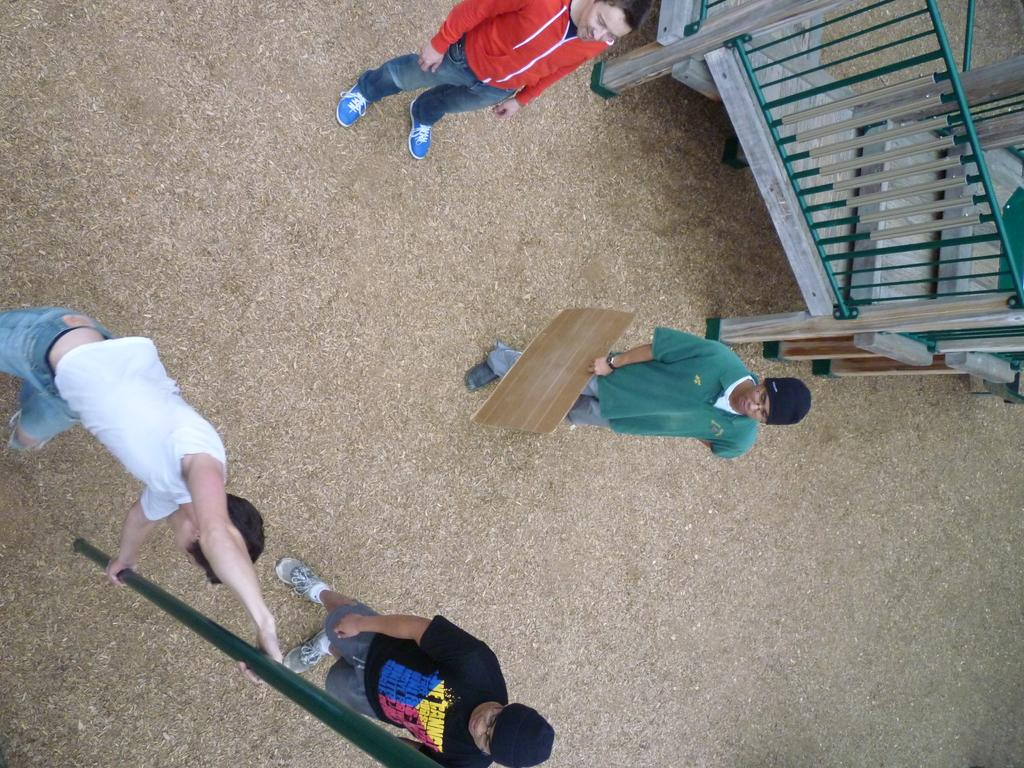What are the people in the image doing? There are people on the ground in the image, but their specific activities are not clear. What object is being held by one of the people? One person is holding a cardboard sheet. What is the other person holding? The other person is holding a pole. What can be seen on the right side of the image? There is a wooden fence on the right side of the image. Can you see a nest in the image? There is no nest present in the image. Is there a partner standing next to the person holding the pole? The image does not show any indication of a partner standing next to the person holding the pole. 